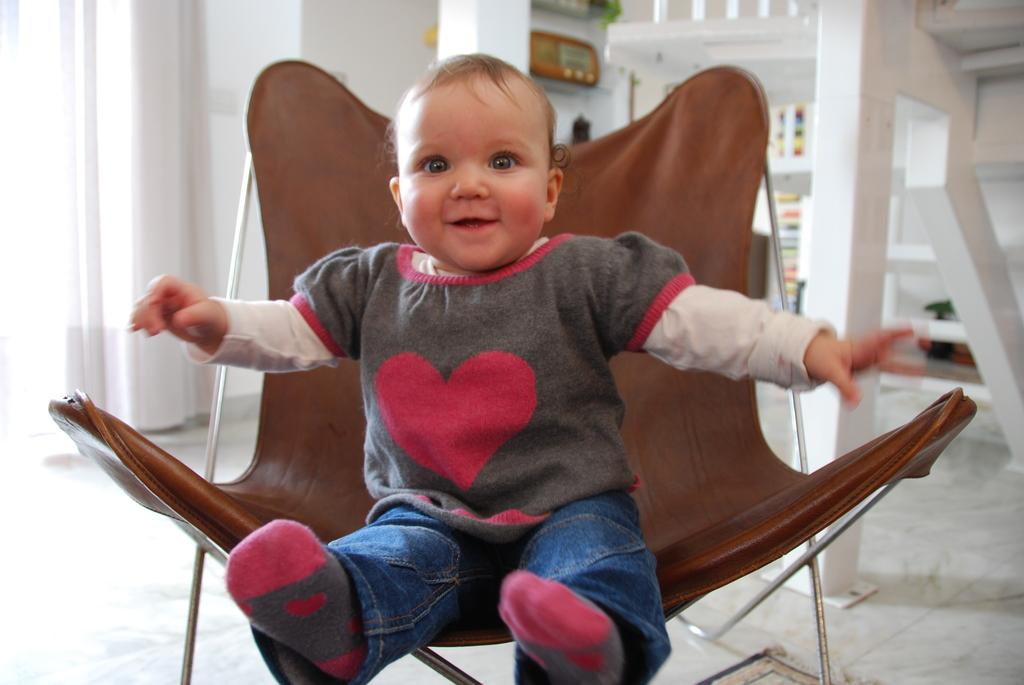What is the main subject of the image? There is a baby in the image. What is the baby doing in the image? The baby is sitting in a chair. What can be seen in the background of the image? There is a wall in the image. Where does the image take place? The image takes place in a room (implied by the mention of "in there"). What type of calculator is the baby using in the image? There is no calculator present in the image. What wish does the baby have while sitting in the chair? The image does not provide any information about the baby's wishes or thoughts. 